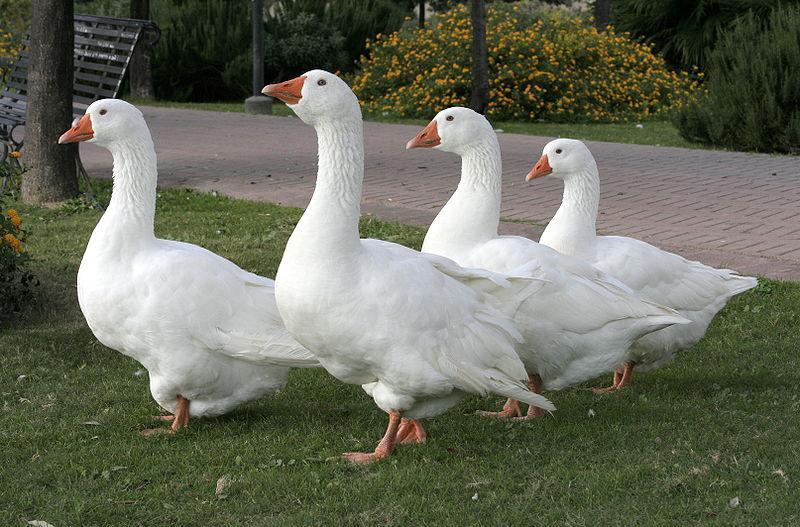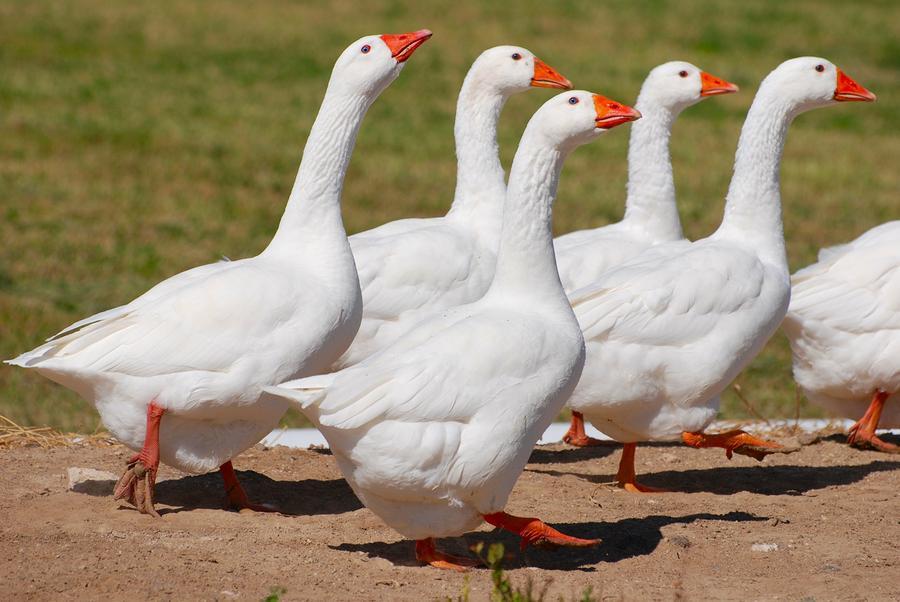The first image is the image on the left, the second image is the image on the right. For the images shown, is this caption "There are 6 or more completely white geese." true? Answer yes or no. Yes. 